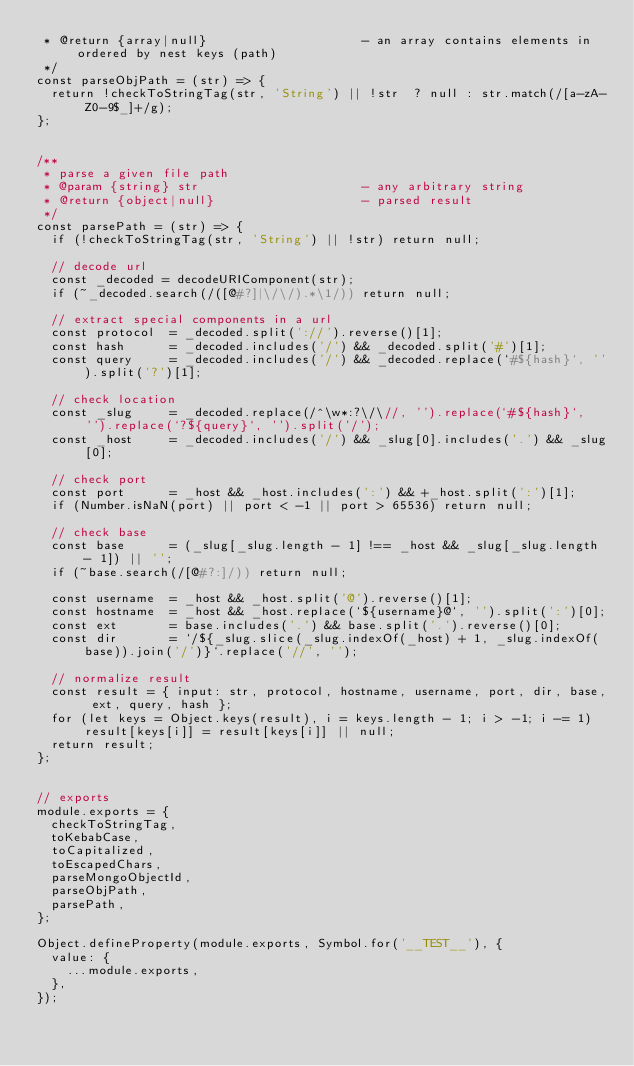Convert code to text. <code><loc_0><loc_0><loc_500><loc_500><_JavaScript_> * @return {array|null}                     - an array contains elements in ordered by nest keys (path)
 */
const parseObjPath = (str) => {
  return !checkToStringTag(str, 'String') || !str  ? null : str.match(/[a-zA-Z0-9$_]+/g);
};


/**
 * parse a given file path
 * @param {string} str                      - any arbitrary string
 * @return {object|null}                    - parsed result
 */
const parsePath = (str) => {
  if (!checkToStringTag(str, 'String') || !str) return null;

  // decode url
  const _decoded = decodeURIComponent(str);
  if (~_decoded.search(/([@#?]|\/\/).*\1/)) return null;

  // extract special components in a url
  const protocol  = _decoded.split('://').reverse()[1];
  const hash      = _decoded.includes('/') && _decoded.split('#')[1];
  const query     = _decoded.includes('/') && _decoded.replace(`#${hash}`, '').split('?')[1];

  // check location
  const _slug     = _decoded.replace(/^\w*:?\/\//, '').replace(`#${hash}`, '').replace(`?${query}`, '').split('/');
  const _host     = _decoded.includes('/') && _slug[0].includes('.') && _slug[0];

  // check port
  const port      = _host && _host.includes(':') && +_host.split(':')[1];
  if (Number.isNaN(port) || port < -1 || port > 65536) return null;

  // check base
  const base      = (_slug[_slug.length - 1] !== _host && _slug[_slug.length - 1]) || '';
  if (~base.search(/[@#?:]/)) return null;

  const username  = _host && _host.split('@').reverse()[1];
  const hostname  = _host && _host.replace(`${username}@`, '').split(':')[0];
  const ext       = base.includes('.') && base.split('.').reverse()[0];
  const dir       = `/${_slug.slice(_slug.indexOf(_host) + 1, _slug.indexOf(base)).join('/')}`.replace('//', '');

  // normalize result
  const result = { input: str, protocol, hostname, username, port, dir, base, ext, query, hash };
  for (let keys = Object.keys(result), i = keys.length - 1; i > -1; i -= 1) result[keys[i]] = result[keys[i]] || null;
  return result;
};


// exports
module.exports = {
  checkToStringTag,
  toKebabCase,
  toCapitalized,
  toEscapedChars,
  parseMongoObjectId,
  parseObjPath,
  parsePath,
};

Object.defineProperty(module.exports, Symbol.for('__TEST__'), {
  value: {
    ...module.exports,
  },
});
</code> 